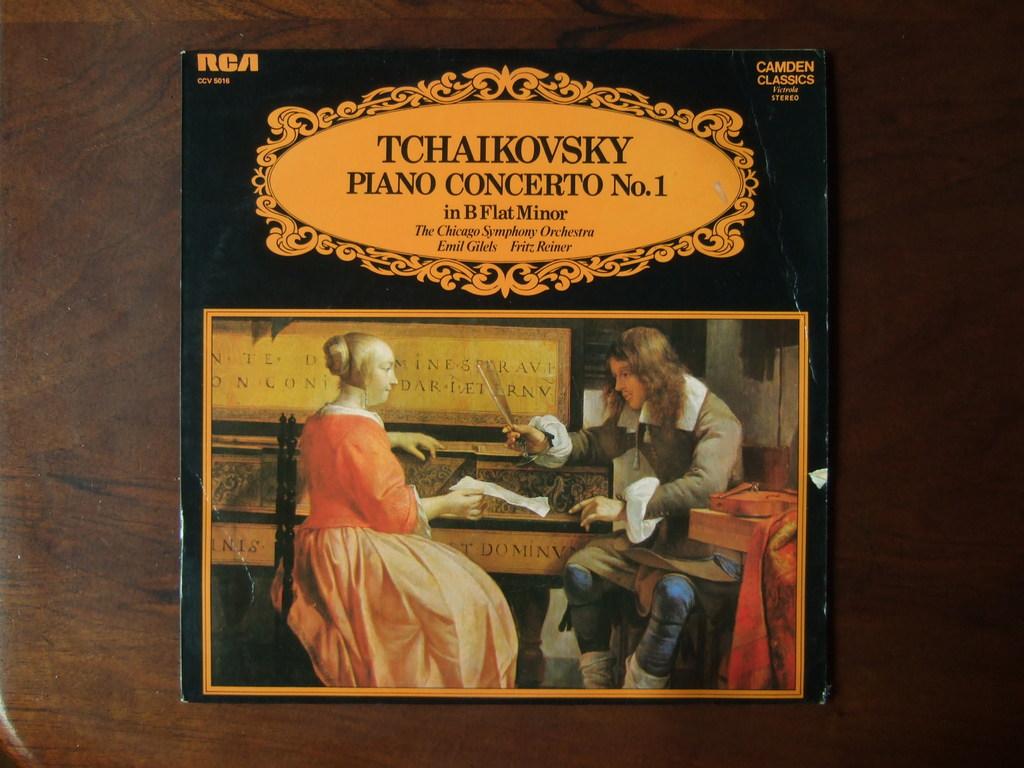Is this about pianos?
Give a very brief answer. Yes. What key is this piece in?
Provide a short and direct response. B flat minor. 